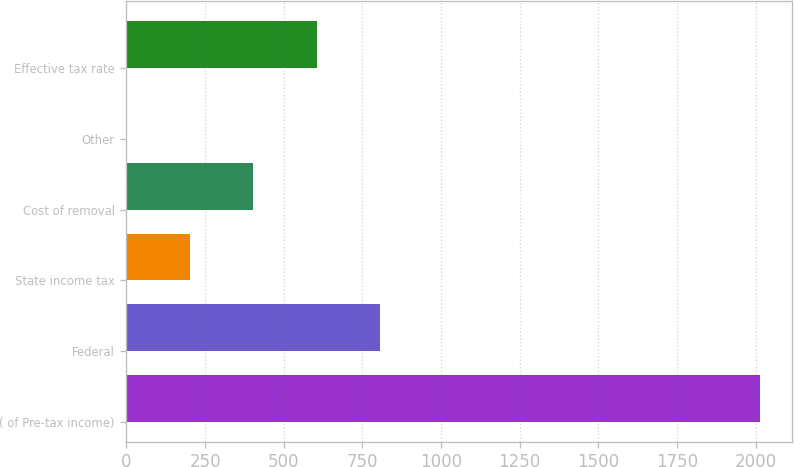Convert chart to OTSL. <chart><loc_0><loc_0><loc_500><loc_500><bar_chart><fcel>( of Pre-tax income)<fcel>Federal<fcel>State income tax<fcel>Cost of removal<fcel>Other<fcel>Effective tax rate<nl><fcel>2014<fcel>806.2<fcel>202.3<fcel>403.6<fcel>1<fcel>604.9<nl></chart> 